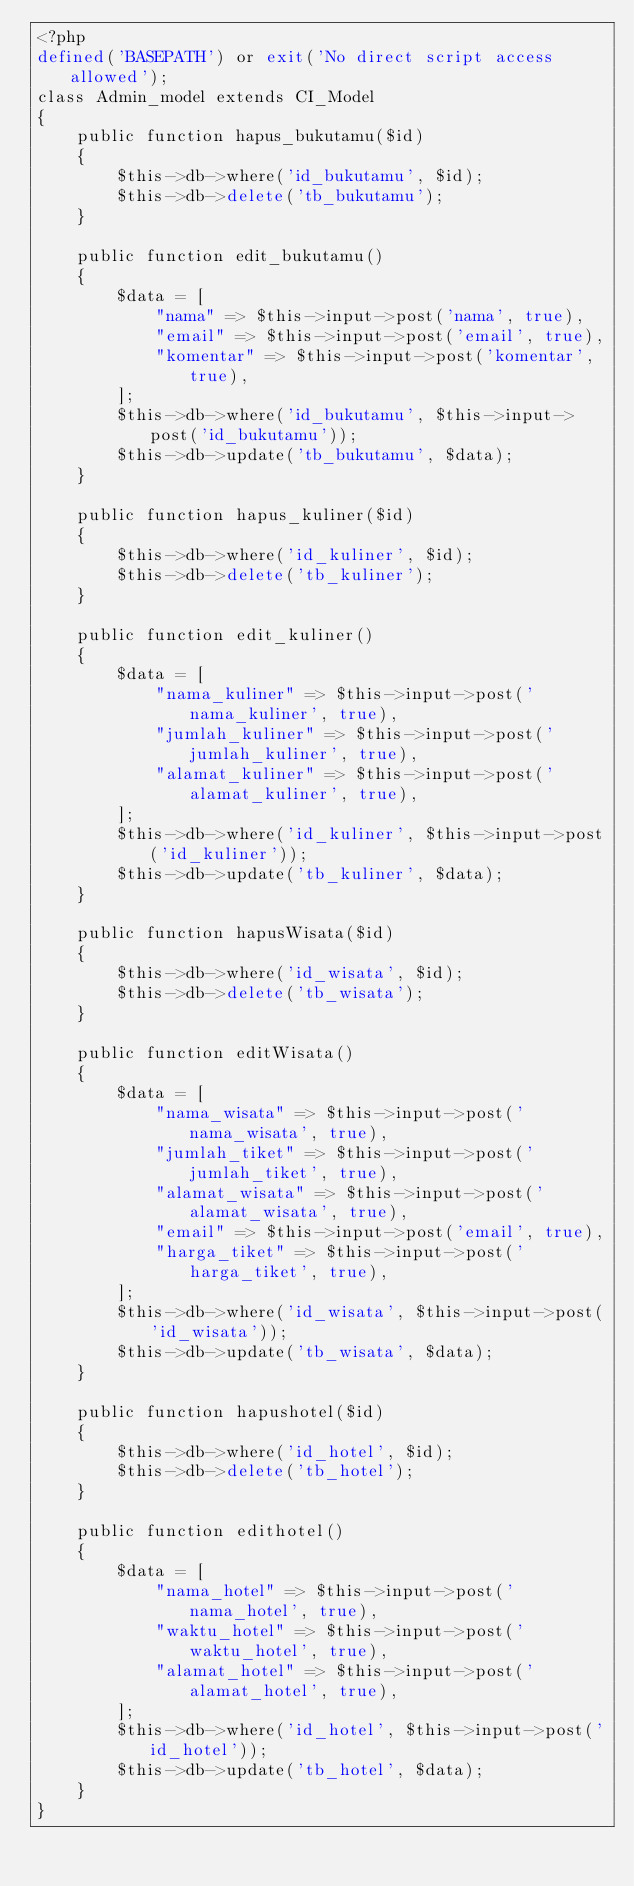<code> <loc_0><loc_0><loc_500><loc_500><_PHP_><?php
defined('BASEPATH') or exit('No direct script access allowed');
class Admin_model extends CI_Model
{
    public function hapus_bukutamu($id)
    {
        $this->db->where('id_bukutamu', $id);
        $this->db->delete('tb_bukutamu');
    }

    public function edit_bukutamu()
    {
        $data = [
            "nama" => $this->input->post('nama', true),
            "email" => $this->input->post('email', true),
            "komentar" => $this->input->post('komentar', true),
        ];
        $this->db->where('id_bukutamu', $this->input->post('id_bukutamu'));
        $this->db->update('tb_bukutamu', $data);
    }

    public function hapus_kuliner($id)
    {
        $this->db->where('id_kuliner', $id);
        $this->db->delete('tb_kuliner');
    }

    public function edit_kuliner()
    {
        $data = [
            "nama_kuliner" => $this->input->post('nama_kuliner', true),
            "jumlah_kuliner" => $this->input->post('jumlah_kuliner', true),
            "alamat_kuliner" => $this->input->post('alamat_kuliner', true),
        ];
        $this->db->where('id_kuliner', $this->input->post('id_kuliner'));
        $this->db->update('tb_kuliner', $data);
    }

    public function hapusWisata($id)
    {
        $this->db->where('id_wisata', $id);
        $this->db->delete('tb_wisata');
    }

    public function editWisata()
    {
        $data = [
            "nama_wisata" => $this->input->post('nama_wisata', true),
            "jumlah_tiket" => $this->input->post('jumlah_tiket', true),
            "alamat_wisata" => $this->input->post('alamat_wisata', true),
            "email" => $this->input->post('email', true),
            "harga_tiket" => $this->input->post('harga_tiket', true),
        ];
        $this->db->where('id_wisata', $this->input->post('id_wisata'));
        $this->db->update('tb_wisata', $data);
    }

    public function hapushotel($id)
    {
        $this->db->where('id_hotel', $id);
        $this->db->delete('tb_hotel');
    }

    public function edithotel()
    {
        $data = [
            "nama_hotel" => $this->input->post('nama_hotel', true),
            "waktu_hotel" => $this->input->post('waktu_hotel', true),
            "alamat_hotel" => $this->input->post('alamat_hotel', true),
        ];
        $this->db->where('id_hotel', $this->input->post('id_hotel'));
        $this->db->update('tb_hotel', $data);
    }
}
</code> 